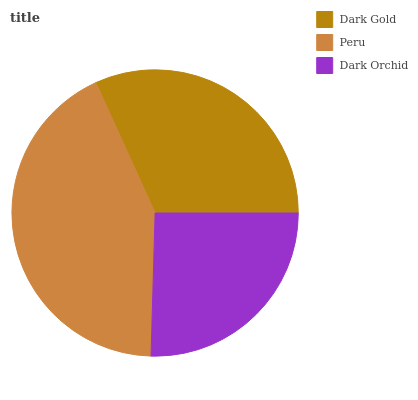Is Dark Orchid the minimum?
Answer yes or no. Yes. Is Peru the maximum?
Answer yes or no. Yes. Is Peru the minimum?
Answer yes or no. No. Is Dark Orchid the maximum?
Answer yes or no. No. Is Peru greater than Dark Orchid?
Answer yes or no. Yes. Is Dark Orchid less than Peru?
Answer yes or no. Yes. Is Dark Orchid greater than Peru?
Answer yes or no. No. Is Peru less than Dark Orchid?
Answer yes or no. No. Is Dark Gold the high median?
Answer yes or no. Yes. Is Dark Gold the low median?
Answer yes or no. Yes. Is Dark Orchid the high median?
Answer yes or no. No. Is Dark Orchid the low median?
Answer yes or no. No. 